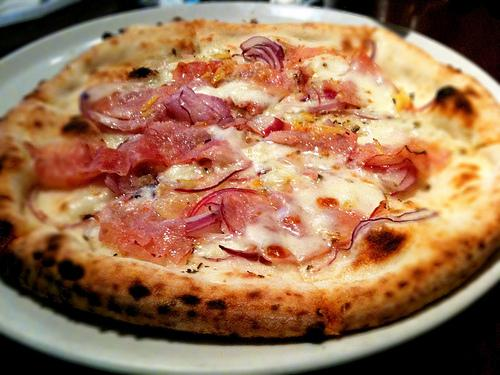Question: where is pizza?
Choices:
A. In oven.
B. In micro wave oven.
C. In box.
D. On plate.
Answer with the letter. Answer: D Question: where is cheese?
Choices:
A. On macaronis.
B. On chicken.
C. On pizza.
D. On hamburger.
Answer with the letter. Answer: C Question: what shape is plate?
Choices:
A. Ovoid.
B. Hexagonal.
C. Square.
D. Round.
Answer with the letter. Answer: D Question: where is crust?
Choices:
A. Pie.
B. Above magma.
C. On his knee.
D. Bottom of pizza.
Answer with the letter. Answer: D Question: what sort of food?
Choices:
A. Sandwich.
B. Pizza.
C. Chicken nuggets.
D. Noodles.
Answer with the letter. Answer: B Question: how many pieces?
Choices:
A. Six.
B. Seven.
C. Five.
D. Four.
Answer with the letter. Answer: A 